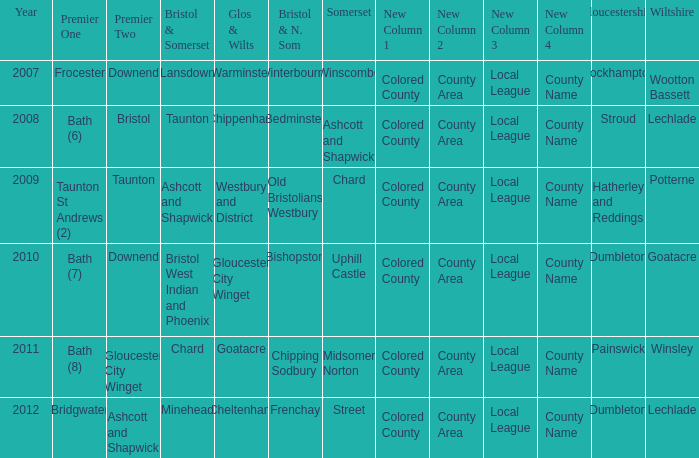What is the year where glos & wilts is gloucester city winget? 2010.0. 